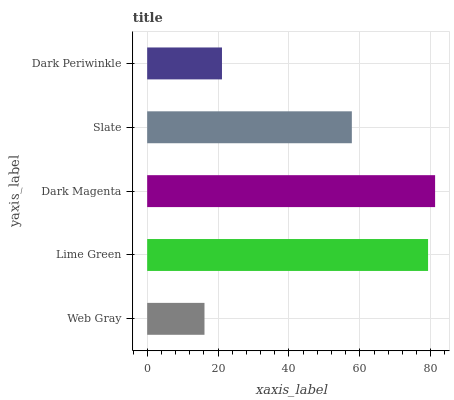Is Web Gray the minimum?
Answer yes or no. Yes. Is Dark Magenta the maximum?
Answer yes or no. Yes. Is Lime Green the minimum?
Answer yes or no. No. Is Lime Green the maximum?
Answer yes or no. No. Is Lime Green greater than Web Gray?
Answer yes or no. Yes. Is Web Gray less than Lime Green?
Answer yes or no. Yes. Is Web Gray greater than Lime Green?
Answer yes or no. No. Is Lime Green less than Web Gray?
Answer yes or no. No. Is Slate the high median?
Answer yes or no. Yes. Is Slate the low median?
Answer yes or no. Yes. Is Web Gray the high median?
Answer yes or no. No. Is Dark Periwinkle the low median?
Answer yes or no. No. 